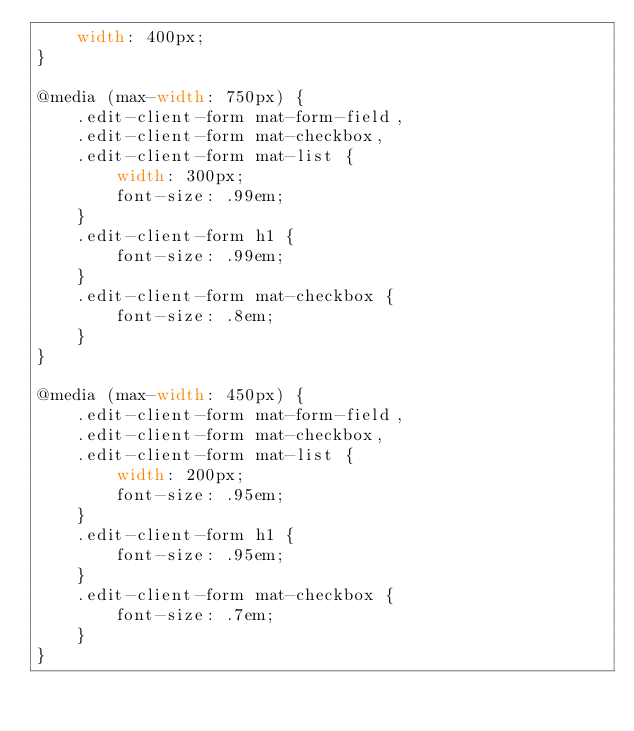Convert code to text. <code><loc_0><loc_0><loc_500><loc_500><_CSS_>    width: 400px;
}

@media (max-width: 750px) {
    .edit-client-form mat-form-field,
    .edit-client-form mat-checkbox,
    .edit-client-form mat-list {
        width: 300px;
        font-size: .99em;
    }
    .edit-client-form h1 {
        font-size: .99em;
    }
    .edit-client-form mat-checkbox {
        font-size: .8em;
    }
}

@media (max-width: 450px) {
    .edit-client-form mat-form-field,
    .edit-client-form mat-checkbox,
    .edit-client-form mat-list {
        width: 200px;
        font-size: .95em;
    }
    .edit-client-form h1 {
        font-size: .95em;
    }
    .edit-client-form mat-checkbox {
        font-size: .7em;
    }
}</code> 